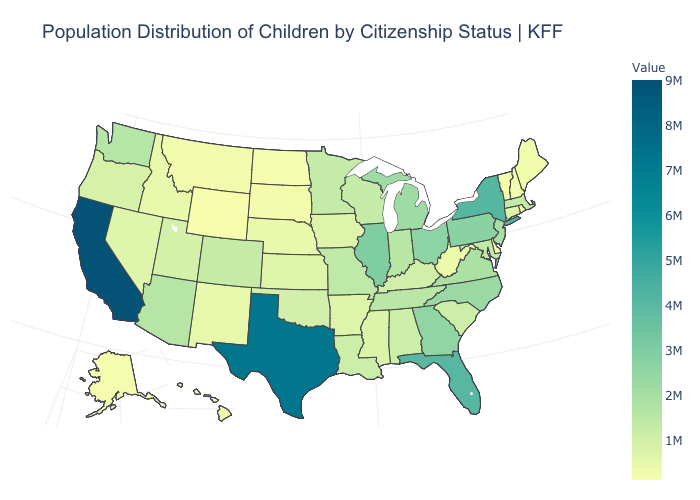Does the map have missing data?
Quick response, please. No. Which states hav the highest value in the West?
Give a very brief answer. California. Does South Carolina have the highest value in the South?
Keep it brief. No. Does Wyoming have the lowest value in the West?
Quick response, please. Yes. Which states have the lowest value in the USA?
Concise answer only. Vermont. Does Wyoming have the lowest value in the West?
Short answer required. Yes. Does New York have a higher value than Texas?
Concise answer only. No. 